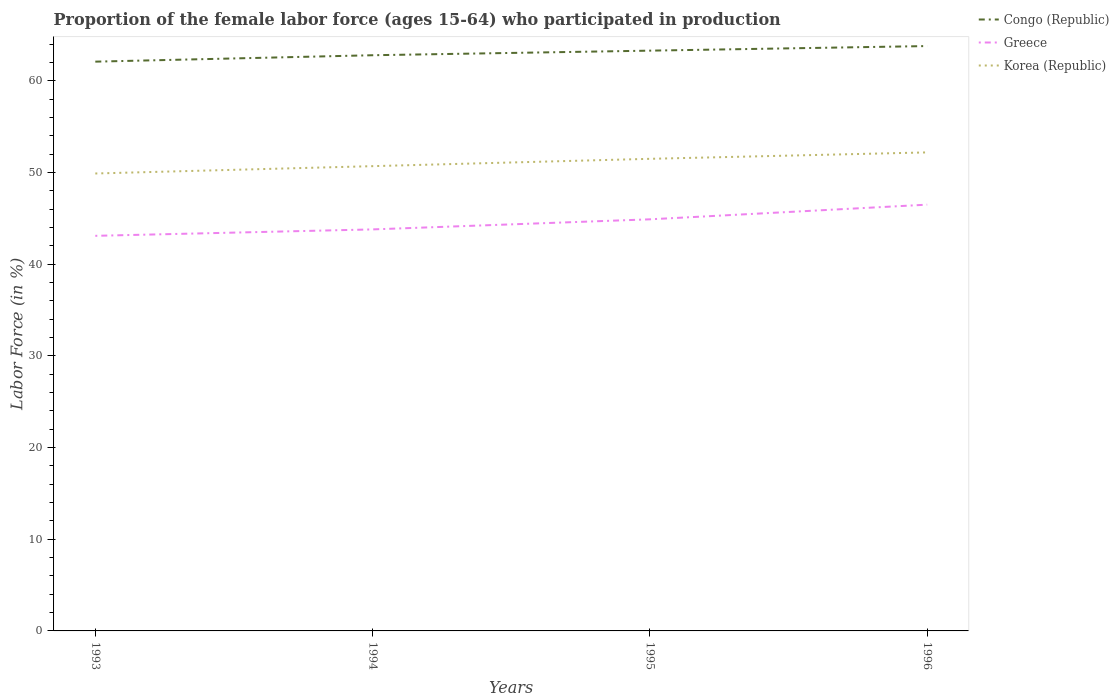Across all years, what is the maximum proportion of the female labor force who participated in production in Congo (Republic)?
Provide a succinct answer. 62.1. In which year was the proportion of the female labor force who participated in production in Greece maximum?
Your response must be concise. 1993. What is the total proportion of the female labor force who participated in production in Korea (Republic) in the graph?
Your answer should be very brief. -2.3. What is the difference between the highest and the second highest proportion of the female labor force who participated in production in Congo (Republic)?
Your answer should be very brief. 1.7. How many years are there in the graph?
Provide a succinct answer. 4. What is the difference between two consecutive major ticks on the Y-axis?
Provide a succinct answer. 10. Are the values on the major ticks of Y-axis written in scientific E-notation?
Make the answer very short. No. Does the graph contain grids?
Keep it short and to the point. No. Where does the legend appear in the graph?
Your response must be concise. Top right. How are the legend labels stacked?
Provide a succinct answer. Vertical. What is the title of the graph?
Give a very brief answer. Proportion of the female labor force (ages 15-64) who participated in production. Does "Curacao" appear as one of the legend labels in the graph?
Make the answer very short. No. What is the label or title of the X-axis?
Ensure brevity in your answer.  Years. What is the Labor Force (in %) in Congo (Republic) in 1993?
Offer a terse response. 62.1. What is the Labor Force (in %) in Greece in 1993?
Make the answer very short. 43.1. What is the Labor Force (in %) in Korea (Republic) in 1993?
Keep it short and to the point. 49.9. What is the Labor Force (in %) of Congo (Republic) in 1994?
Your response must be concise. 62.8. What is the Labor Force (in %) in Greece in 1994?
Keep it short and to the point. 43.8. What is the Labor Force (in %) in Korea (Republic) in 1994?
Provide a short and direct response. 50.7. What is the Labor Force (in %) in Congo (Republic) in 1995?
Your answer should be compact. 63.3. What is the Labor Force (in %) of Greece in 1995?
Make the answer very short. 44.9. What is the Labor Force (in %) of Korea (Republic) in 1995?
Your answer should be compact. 51.5. What is the Labor Force (in %) in Congo (Republic) in 1996?
Keep it short and to the point. 63.8. What is the Labor Force (in %) in Greece in 1996?
Provide a short and direct response. 46.5. What is the Labor Force (in %) in Korea (Republic) in 1996?
Your response must be concise. 52.2. Across all years, what is the maximum Labor Force (in %) in Congo (Republic)?
Give a very brief answer. 63.8. Across all years, what is the maximum Labor Force (in %) in Greece?
Ensure brevity in your answer.  46.5. Across all years, what is the maximum Labor Force (in %) of Korea (Republic)?
Provide a short and direct response. 52.2. Across all years, what is the minimum Labor Force (in %) of Congo (Republic)?
Offer a very short reply. 62.1. Across all years, what is the minimum Labor Force (in %) of Greece?
Your answer should be very brief. 43.1. Across all years, what is the minimum Labor Force (in %) in Korea (Republic)?
Ensure brevity in your answer.  49.9. What is the total Labor Force (in %) in Congo (Republic) in the graph?
Keep it short and to the point. 252. What is the total Labor Force (in %) in Greece in the graph?
Make the answer very short. 178.3. What is the total Labor Force (in %) of Korea (Republic) in the graph?
Your response must be concise. 204.3. What is the difference between the Labor Force (in %) of Korea (Republic) in 1993 and that in 1995?
Your response must be concise. -1.6. What is the difference between the Labor Force (in %) of Korea (Republic) in 1993 and that in 1996?
Your response must be concise. -2.3. What is the difference between the Labor Force (in %) in Korea (Republic) in 1994 and that in 1995?
Offer a terse response. -0.8. What is the difference between the Labor Force (in %) in Greece in 1994 and that in 1996?
Your response must be concise. -2.7. What is the difference between the Labor Force (in %) in Korea (Republic) in 1994 and that in 1996?
Keep it short and to the point. -1.5. What is the difference between the Labor Force (in %) in Greece in 1995 and that in 1996?
Your answer should be very brief. -1.6. What is the difference between the Labor Force (in %) of Korea (Republic) in 1995 and that in 1996?
Your response must be concise. -0.7. What is the difference between the Labor Force (in %) in Greece in 1993 and the Labor Force (in %) in Korea (Republic) in 1994?
Provide a short and direct response. -7.6. What is the difference between the Labor Force (in %) in Congo (Republic) in 1993 and the Labor Force (in %) in Korea (Republic) in 1995?
Your response must be concise. 10.6. What is the difference between the Labor Force (in %) of Greece in 1993 and the Labor Force (in %) of Korea (Republic) in 1995?
Offer a terse response. -8.4. What is the difference between the Labor Force (in %) in Congo (Republic) in 1993 and the Labor Force (in %) in Greece in 1996?
Provide a short and direct response. 15.6. What is the difference between the Labor Force (in %) in Congo (Republic) in 1993 and the Labor Force (in %) in Korea (Republic) in 1996?
Your answer should be very brief. 9.9. What is the difference between the Labor Force (in %) of Congo (Republic) in 1994 and the Labor Force (in %) of Greece in 1995?
Ensure brevity in your answer.  17.9. What is the difference between the Labor Force (in %) of Congo (Republic) in 1994 and the Labor Force (in %) of Korea (Republic) in 1996?
Offer a terse response. 10.6. What is the difference between the Labor Force (in %) of Greece in 1995 and the Labor Force (in %) of Korea (Republic) in 1996?
Your response must be concise. -7.3. What is the average Labor Force (in %) in Congo (Republic) per year?
Offer a terse response. 63. What is the average Labor Force (in %) of Greece per year?
Offer a very short reply. 44.58. What is the average Labor Force (in %) of Korea (Republic) per year?
Make the answer very short. 51.08. In the year 1993, what is the difference between the Labor Force (in %) of Congo (Republic) and Labor Force (in %) of Korea (Republic)?
Keep it short and to the point. 12.2. In the year 1993, what is the difference between the Labor Force (in %) in Greece and Labor Force (in %) in Korea (Republic)?
Give a very brief answer. -6.8. In the year 1994, what is the difference between the Labor Force (in %) in Congo (Republic) and Labor Force (in %) in Greece?
Your answer should be compact. 19. In the year 1994, what is the difference between the Labor Force (in %) in Greece and Labor Force (in %) in Korea (Republic)?
Keep it short and to the point. -6.9. In the year 1995, what is the difference between the Labor Force (in %) in Congo (Republic) and Labor Force (in %) in Korea (Republic)?
Ensure brevity in your answer.  11.8. In the year 1995, what is the difference between the Labor Force (in %) in Greece and Labor Force (in %) in Korea (Republic)?
Offer a terse response. -6.6. In the year 1996, what is the difference between the Labor Force (in %) in Congo (Republic) and Labor Force (in %) in Greece?
Provide a succinct answer. 17.3. In the year 1996, what is the difference between the Labor Force (in %) of Congo (Republic) and Labor Force (in %) of Korea (Republic)?
Offer a very short reply. 11.6. In the year 1996, what is the difference between the Labor Force (in %) of Greece and Labor Force (in %) of Korea (Republic)?
Keep it short and to the point. -5.7. What is the ratio of the Labor Force (in %) in Congo (Republic) in 1993 to that in 1994?
Your response must be concise. 0.99. What is the ratio of the Labor Force (in %) of Korea (Republic) in 1993 to that in 1994?
Ensure brevity in your answer.  0.98. What is the ratio of the Labor Force (in %) in Congo (Republic) in 1993 to that in 1995?
Ensure brevity in your answer.  0.98. What is the ratio of the Labor Force (in %) in Greece in 1993 to that in 1995?
Your answer should be compact. 0.96. What is the ratio of the Labor Force (in %) of Korea (Republic) in 1993 to that in 1995?
Provide a short and direct response. 0.97. What is the ratio of the Labor Force (in %) of Congo (Republic) in 1993 to that in 1996?
Give a very brief answer. 0.97. What is the ratio of the Labor Force (in %) of Greece in 1993 to that in 1996?
Keep it short and to the point. 0.93. What is the ratio of the Labor Force (in %) of Korea (Republic) in 1993 to that in 1996?
Your answer should be compact. 0.96. What is the ratio of the Labor Force (in %) of Greece in 1994 to that in 1995?
Ensure brevity in your answer.  0.98. What is the ratio of the Labor Force (in %) of Korea (Republic) in 1994 to that in 1995?
Your response must be concise. 0.98. What is the ratio of the Labor Force (in %) of Congo (Republic) in 1994 to that in 1996?
Give a very brief answer. 0.98. What is the ratio of the Labor Force (in %) of Greece in 1994 to that in 1996?
Keep it short and to the point. 0.94. What is the ratio of the Labor Force (in %) in Korea (Republic) in 1994 to that in 1996?
Offer a terse response. 0.97. What is the ratio of the Labor Force (in %) of Congo (Republic) in 1995 to that in 1996?
Give a very brief answer. 0.99. What is the ratio of the Labor Force (in %) in Greece in 1995 to that in 1996?
Your answer should be very brief. 0.97. What is the ratio of the Labor Force (in %) of Korea (Republic) in 1995 to that in 1996?
Offer a terse response. 0.99. What is the difference between the highest and the lowest Labor Force (in %) in Congo (Republic)?
Make the answer very short. 1.7. What is the difference between the highest and the lowest Labor Force (in %) of Greece?
Provide a short and direct response. 3.4. 